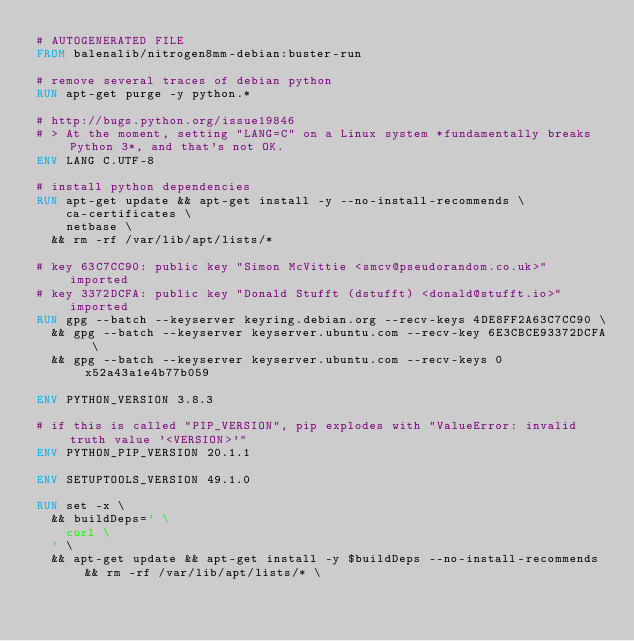Convert code to text. <code><loc_0><loc_0><loc_500><loc_500><_Dockerfile_># AUTOGENERATED FILE
FROM balenalib/nitrogen8mm-debian:buster-run

# remove several traces of debian python
RUN apt-get purge -y python.*

# http://bugs.python.org/issue19846
# > At the moment, setting "LANG=C" on a Linux system *fundamentally breaks Python 3*, and that's not OK.
ENV LANG C.UTF-8

# install python dependencies
RUN apt-get update && apt-get install -y --no-install-recommends \
		ca-certificates \
		netbase \
	&& rm -rf /var/lib/apt/lists/*

# key 63C7CC90: public key "Simon McVittie <smcv@pseudorandom.co.uk>" imported
# key 3372DCFA: public key "Donald Stufft (dstufft) <donald@stufft.io>" imported
RUN gpg --batch --keyserver keyring.debian.org --recv-keys 4DE8FF2A63C7CC90 \
	&& gpg --batch --keyserver keyserver.ubuntu.com --recv-key 6E3CBCE93372DCFA \
	&& gpg --batch --keyserver keyserver.ubuntu.com --recv-keys 0x52a43a1e4b77b059

ENV PYTHON_VERSION 3.8.3

# if this is called "PIP_VERSION", pip explodes with "ValueError: invalid truth value '<VERSION>'"
ENV PYTHON_PIP_VERSION 20.1.1

ENV SETUPTOOLS_VERSION 49.1.0

RUN set -x \
	&& buildDeps=' \
		curl \
	' \
	&& apt-get update && apt-get install -y $buildDeps --no-install-recommends && rm -rf /var/lib/apt/lists/* \</code> 